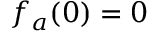Convert formula to latex. <formula><loc_0><loc_0><loc_500><loc_500>f _ { a } ( 0 ) = 0</formula> 